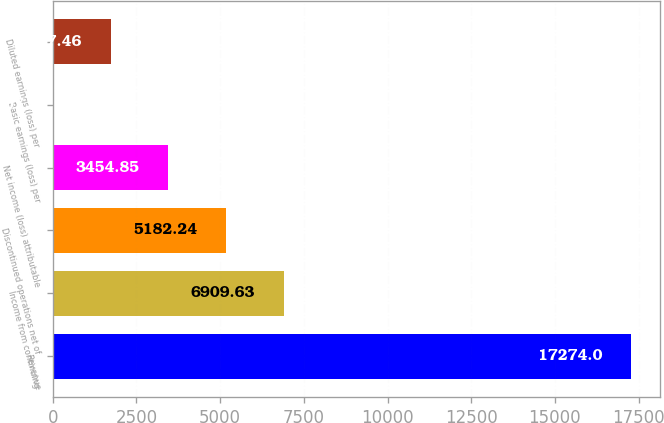<chart> <loc_0><loc_0><loc_500><loc_500><bar_chart><fcel>Revenue<fcel>Income from continuing<fcel>Discontinued operations net of<fcel>Net income (loss) attributable<fcel>Basic earnings (loss) per<fcel>Diluted earnings (loss) per<nl><fcel>17274<fcel>6909.63<fcel>5182.24<fcel>3454.85<fcel>0.07<fcel>1727.46<nl></chart> 